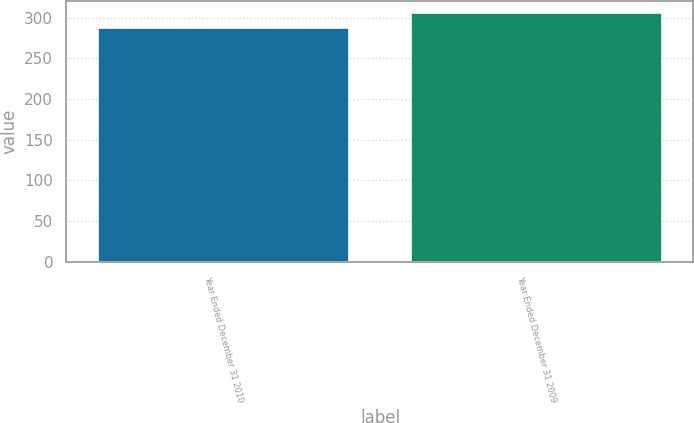<chart> <loc_0><loc_0><loc_500><loc_500><bar_chart><fcel>Year Ended December 31 2010<fcel>Year Ended December 31 2009<nl><fcel>287<fcel>306<nl></chart> 